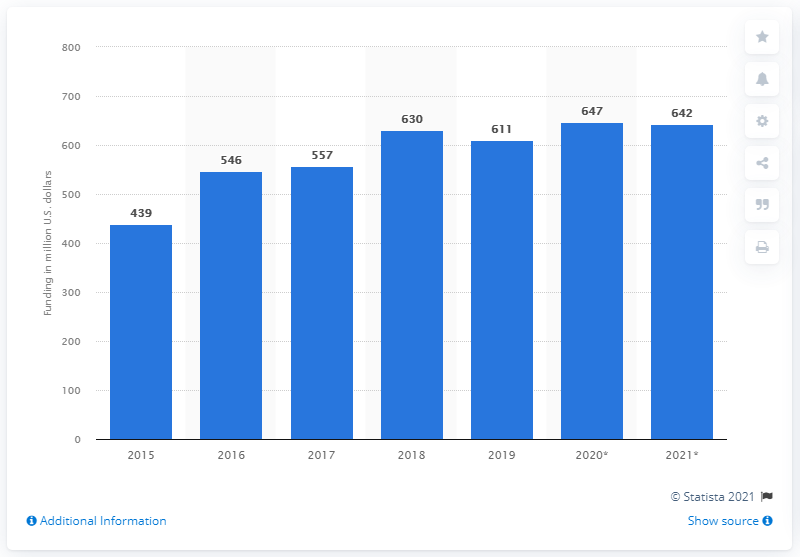Specify some key components in this picture. The total funding for vector-borne disease by the National Institutes of Health (NIH) in fiscal year 2018 was approximately $630 million. 